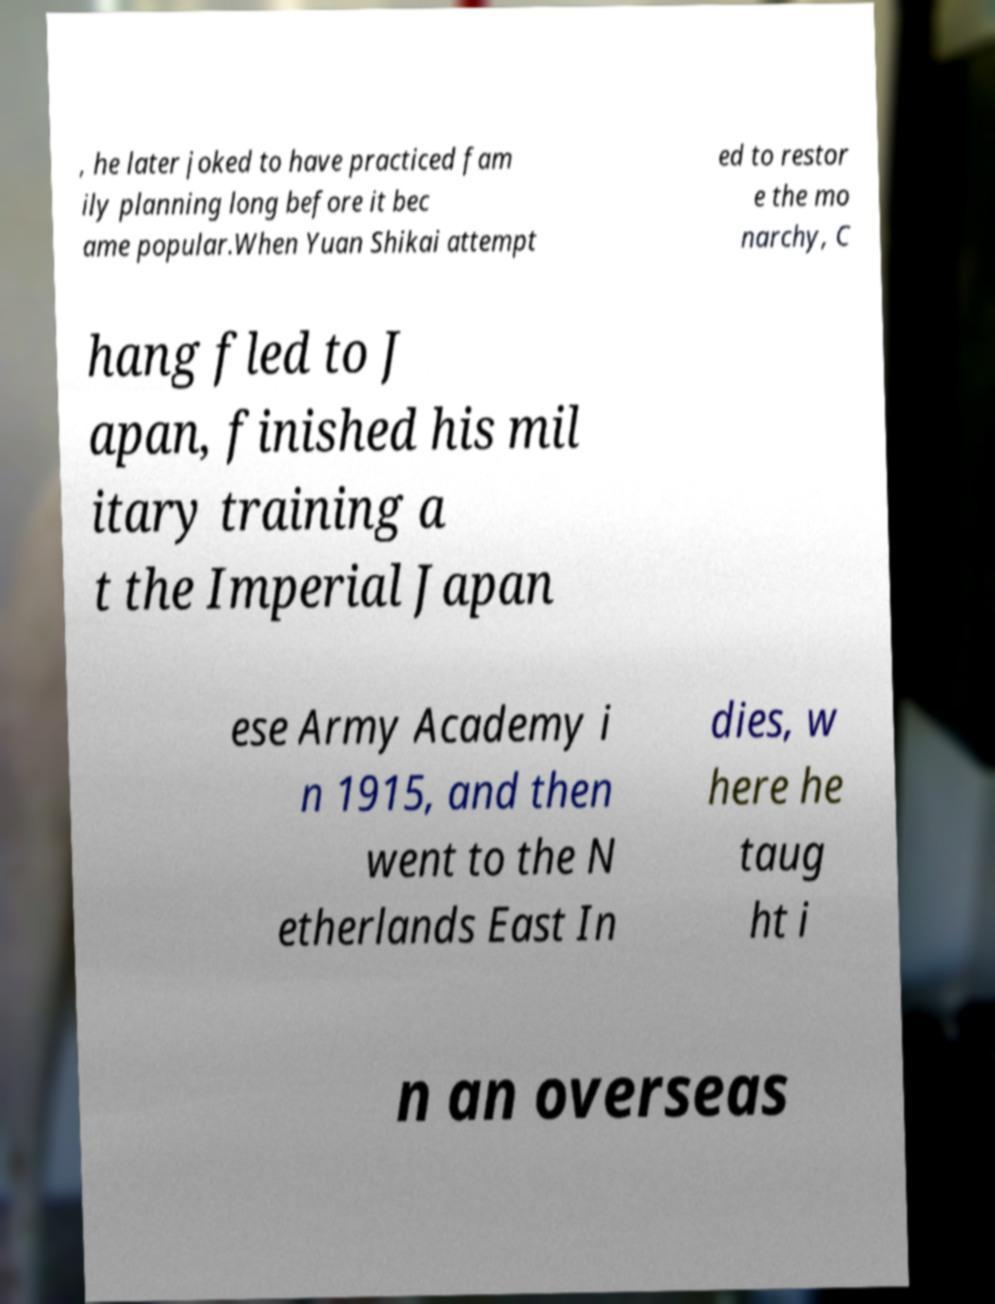What messages or text are displayed in this image? I need them in a readable, typed format. , he later joked to have practiced fam ily planning long before it bec ame popular.When Yuan Shikai attempt ed to restor e the mo narchy, C hang fled to J apan, finished his mil itary training a t the Imperial Japan ese Army Academy i n 1915, and then went to the N etherlands East In dies, w here he taug ht i n an overseas 